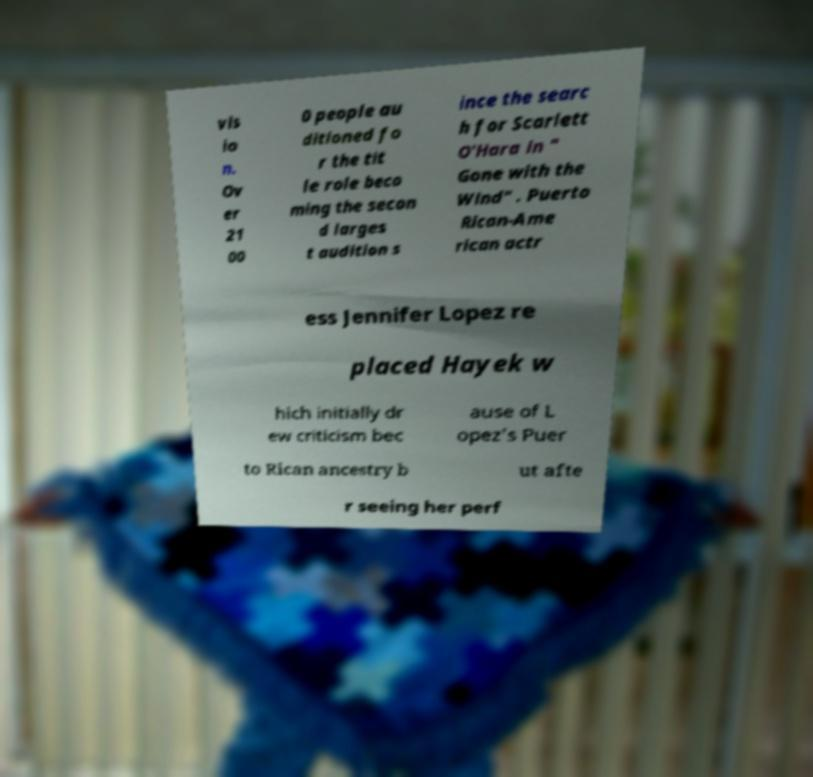I need the written content from this picture converted into text. Can you do that? vis io n. Ov er 21 00 0 people au ditioned fo r the tit le role beco ming the secon d larges t audition s ince the searc h for Scarlett O'Hara in " Gone with the Wind" . Puerto Rican-Ame rican actr ess Jennifer Lopez re placed Hayek w hich initially dr ew criticism bec ause of L opez's Puer to Rican ancestry b ut afte r seeing her perf 